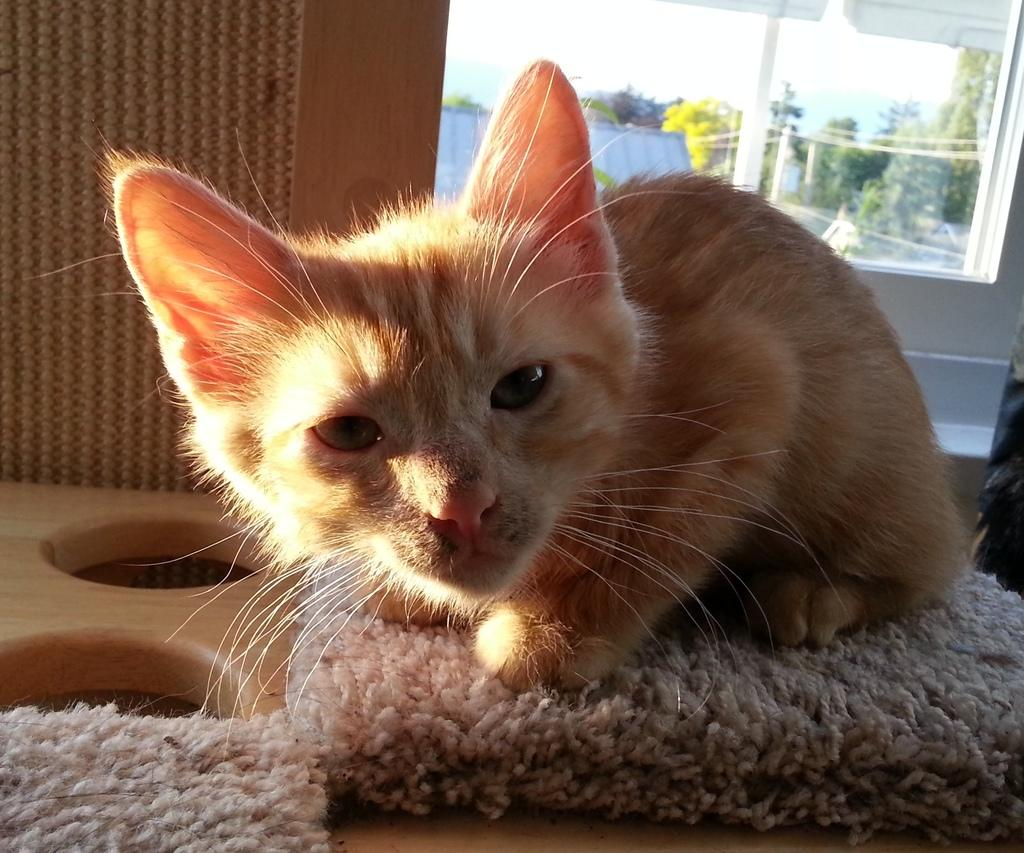What type of animal is in the image? There is a kitten in the image. What is on the right side of the image? There is a glass window on the right side of the image. What can be seen outside the window? Trees are visible outside the window. What type of nut is being used to spread jam on the kitten in the image? There is no nut or jam present in the image; it only features a kitten and a window with trees outside. 